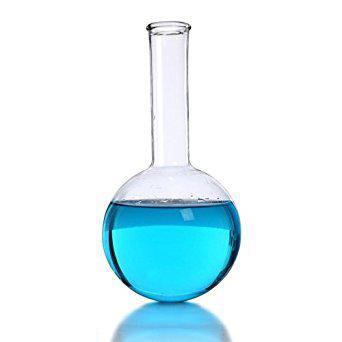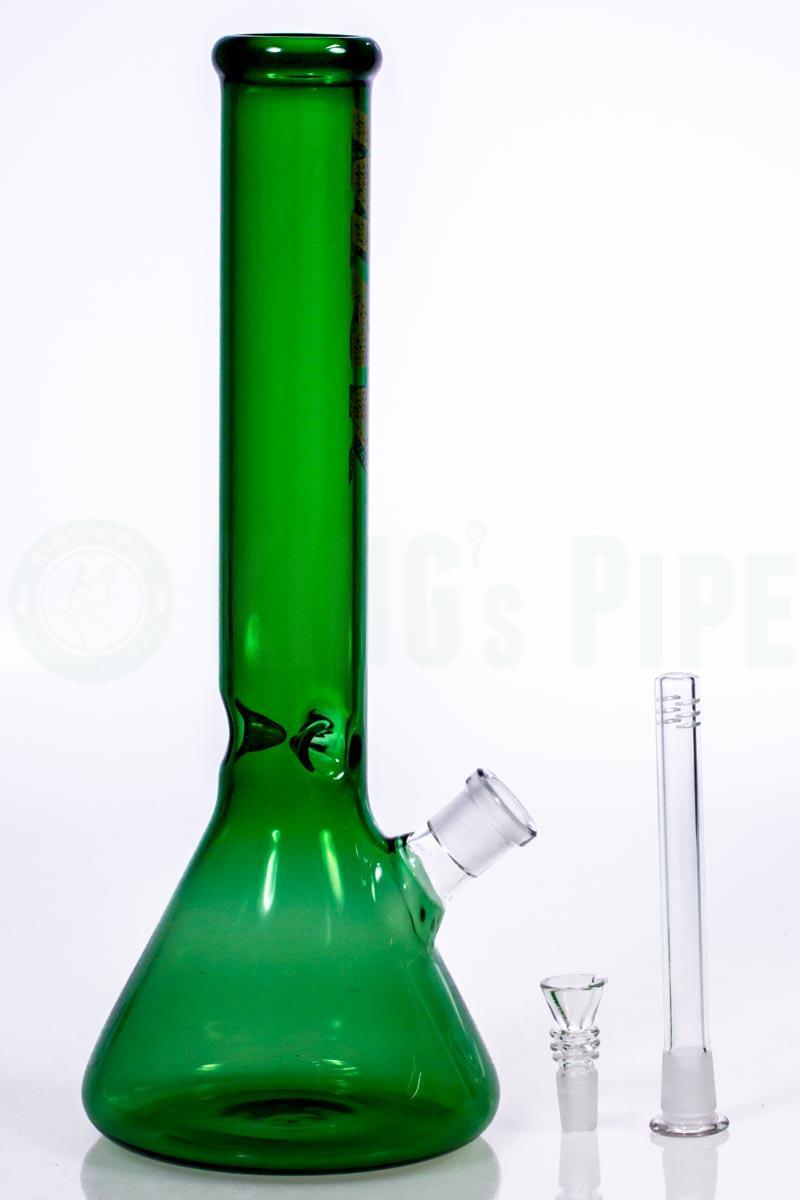The first image is the image on the left, the second image is the image on the right. Assess this claim about the two images: "There is one empty container in the left image.". Correct or not? Answer yes or no. No. The first image is the image on the left, the second image is the image on the right. Analyze the images presented: Is the assertion "There are two science beakers." valid? Answer yes or no. No. 